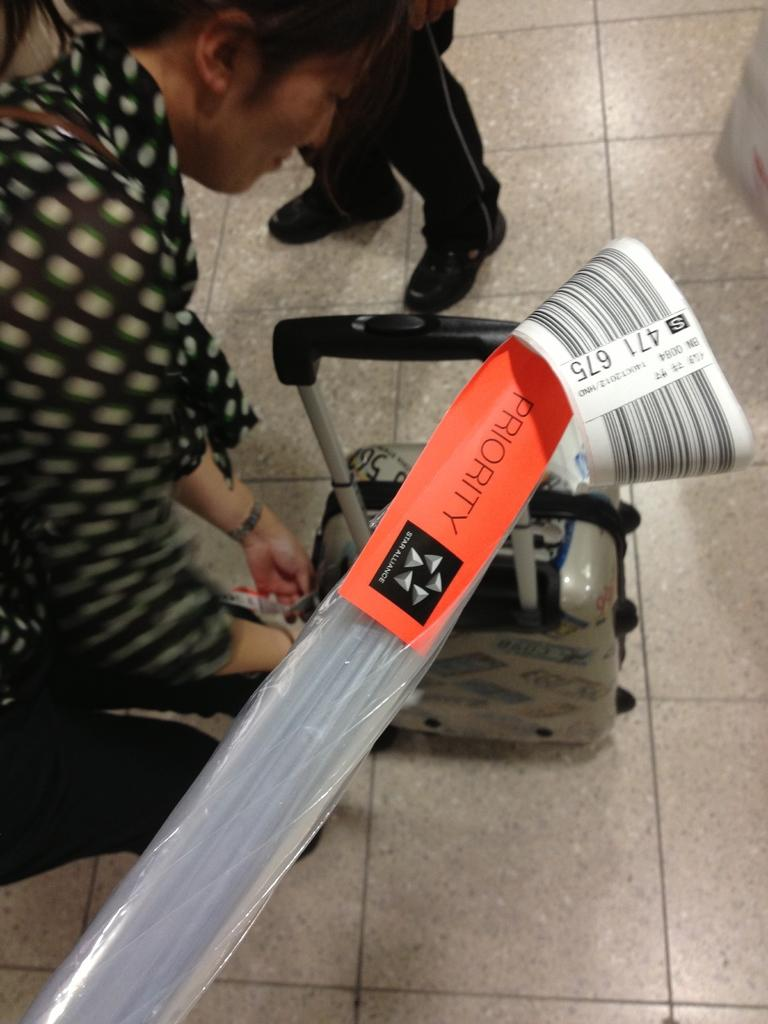What are the persons in the image wearing? The persons in the image are wearing clothes. What object can be seen in the middle of the image? There is a trolley bag and a plastic cover in the middle of the image. What type of air can be seen in the image? There is no air visible in the image; it is a still image. Is there a crib present in the image? No, there is no crib present in the image. 